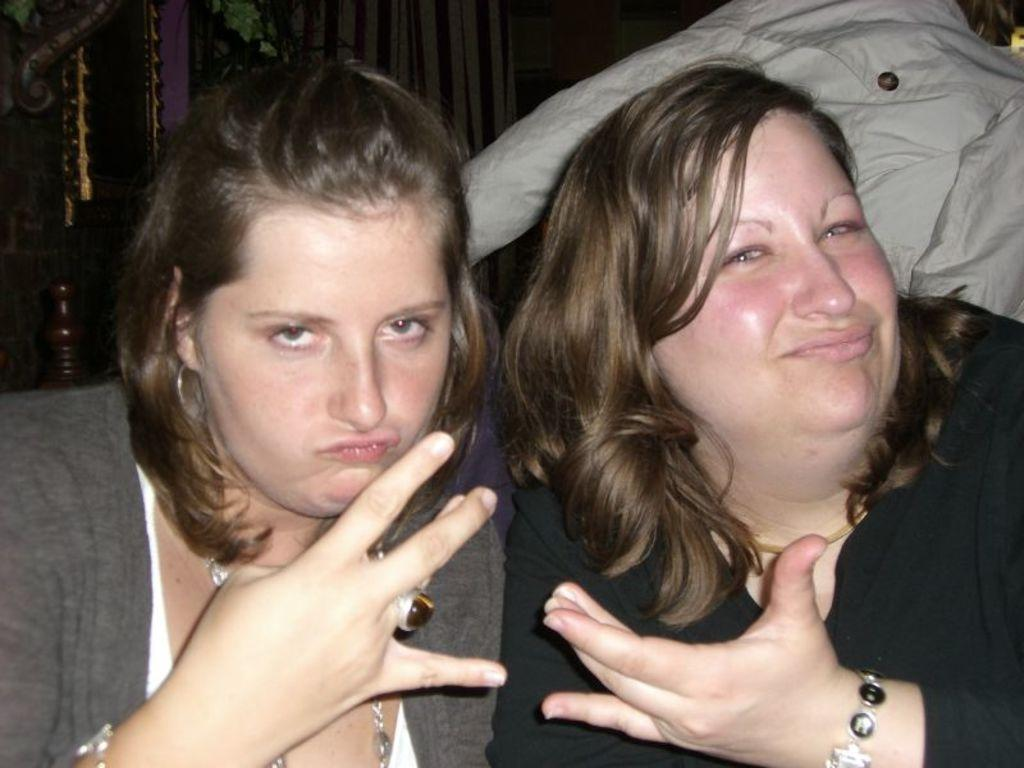How many women are present in the image? There are two women in the image. What are the women doing in the image? The women are posing for a camera. Can you describe any additional objects or elements in the image? Yes, there is a cloth in the image. What type of snake can be seen wrapped around the women in the image? There is no snake present in the image; it only features two women posing for a camera and a cloth. 